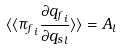<formula> <loc_0><loc_0><loc_500><loc_500>\langle \langle { \pi _ { f } } _ { i } \frac { \partial { q _ { f } } _ { i } } { \partial { q _ { s } } _ { l } } \rangle \rangle = A _ { l }</formula> 